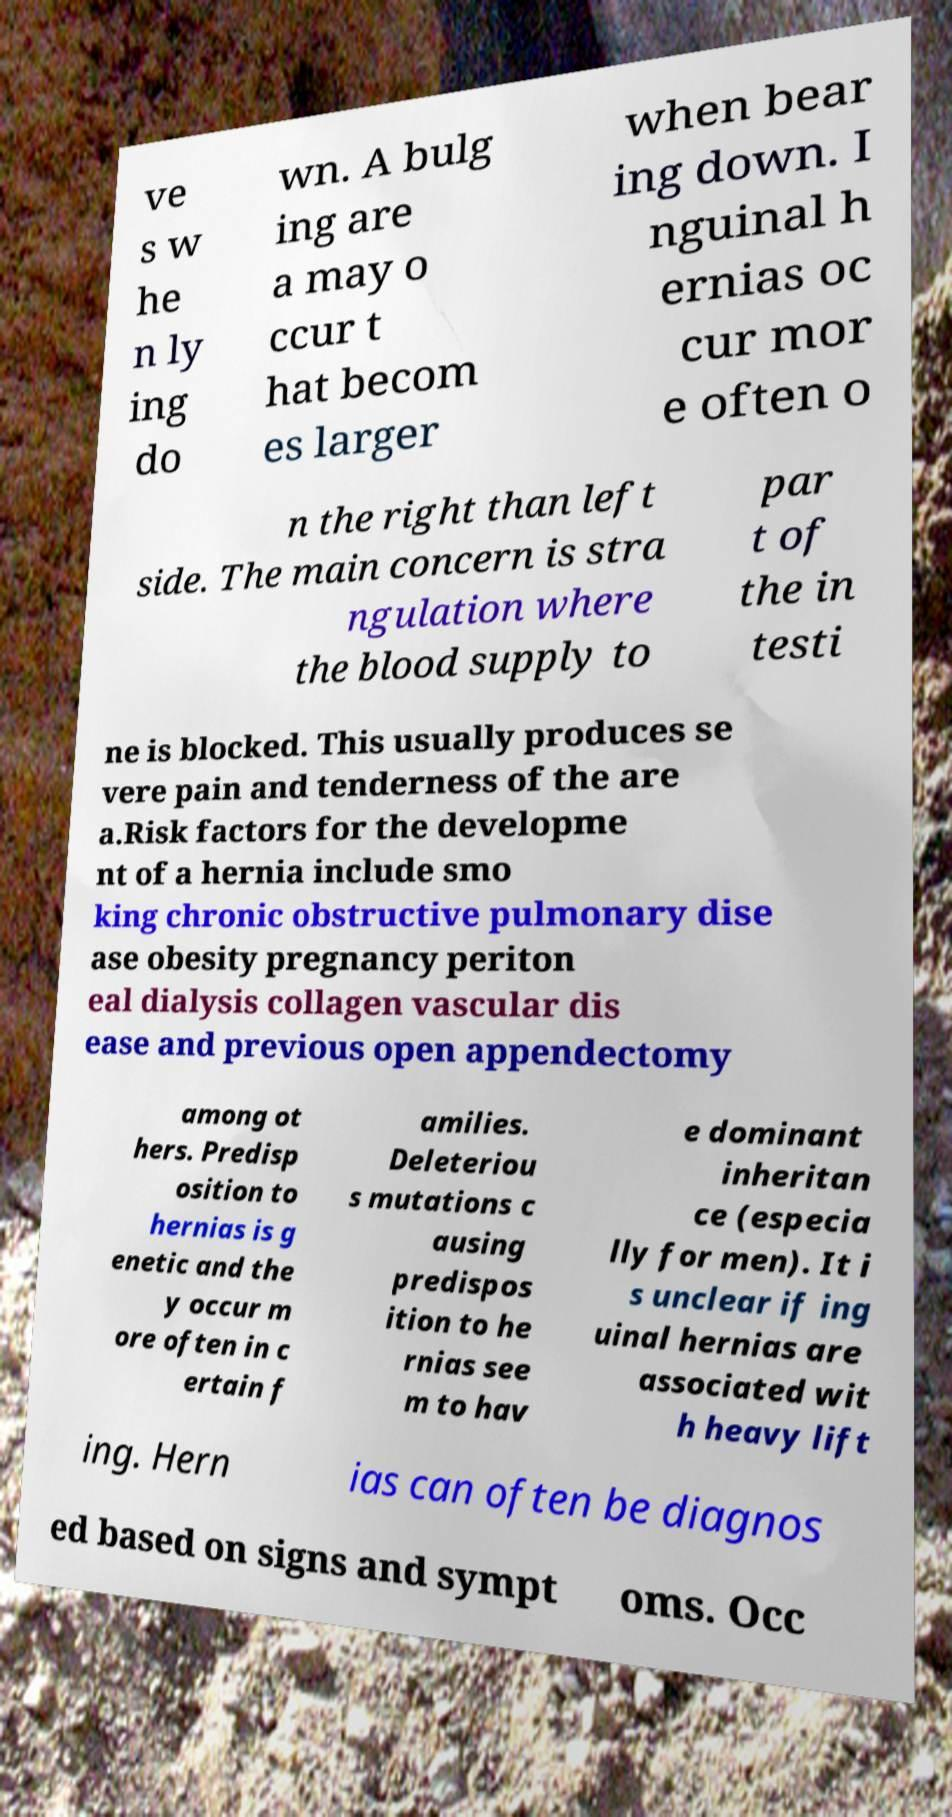Please read and relay the text visible in this image. What does it say? ve s w he n ly ing do wn. A bulg ing are a may o ccur t hat becom es larger when bear ing down. I nguinal h ernias oc cur mor e often o n the right than left side. The main concern is stra ngulation where the blood supply to par t of the in testi ne is blocked. This usually produces se vere pain and tenderness of the are a.Risk factors for the developme nt of a hernia include smo king chronic obstructive pulmonary dise ase obesity pregnancy periton eal dialysis collagen vascular dis ease and previous open appendectomy among ot hers. Predisp osition to hernias is g enetic and the y occur m ore often in c ertain f amilies. Deleteriou s mutations c ausing predispos ition to he rnias see m to hav e dominant inheritan ce (especia lly for men). It i s unclear if ing uinal hernias are associated wit h heavy lift ing. Hern ias can often be diagnos ed based on signs and sympt oms. Occ 